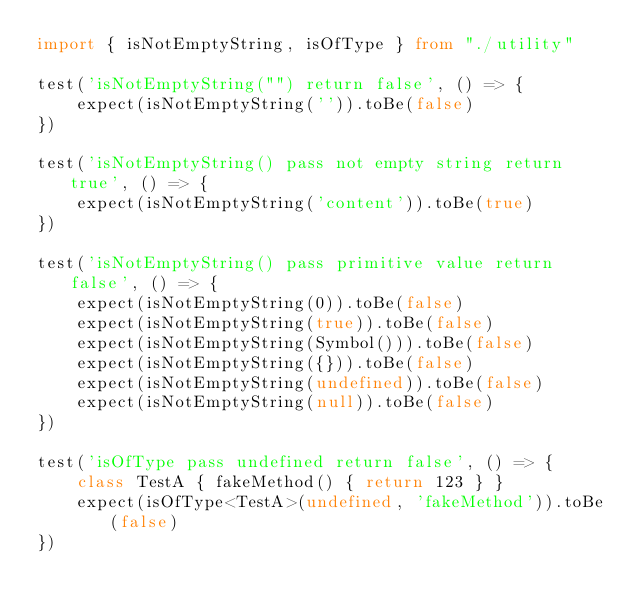<code> <loc_0><loc_0><loc_500><loc_500><_TypeScript_>import { isNotEmptyString, isOfType } from "./utility"

test('isNotEmptyString("") return false', () => {
    expect(isNotEmptyString('')).toBe(false)
})

test('isNotEmptyString() pass not empty string return true', () => {
    expect(isNotEmptyString('content')).toBe(true)
})

test('isNotEmptyString() pass primitive value return false', () => {
    expect(isNotEmptyString(0)).toBe(false)
    expect(isNotEmptyString(true)).toBe(false)
    expect(isNotEmptyString(Symbol())).toBe(false)
    expect(isNotEmptyString({})).toBe(false)
    expect(isNotEmptyString(undefined)).toBe(false)
    expect(isNotEmptyString(null)).toBe(false)
})

test('isOfType pass undefined return false', () => {
    class TestA { fakeMethod() { return 123 } }
    expect(isOfType<TestA>(undefined, 'fakeMethod')).toBe(false)
})</code> 